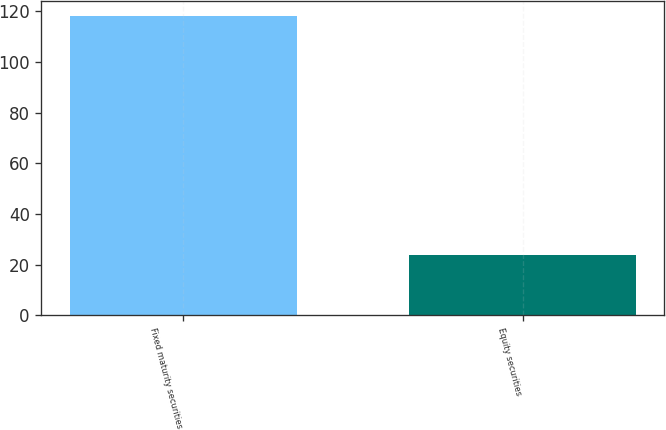Convert chart. <chart><loc_0><loc_0><loc_500><loc_500><bar_chart><fcel>Fixed maturity securities<fcel>Equity securities<nl><fcel>118<fcel>24<nl></chart> 